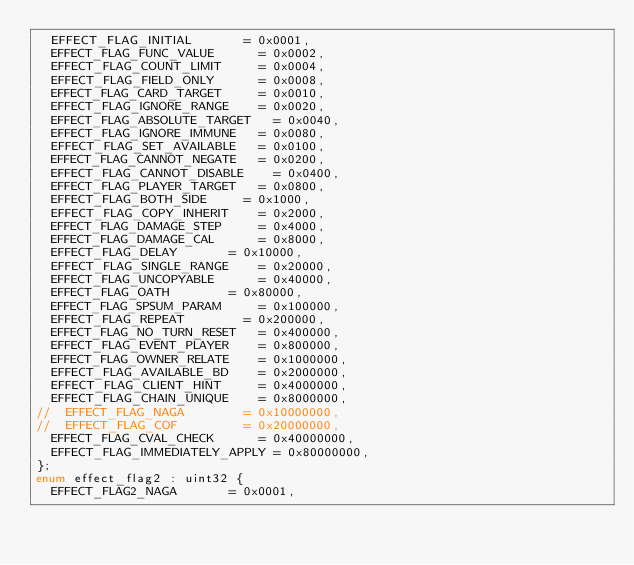<code> <loc_0><loc_0><loc_500><loc_500><_C_>	EFFECT_FLAG_INITIAL				= 0x0001,
	EFFECT_FLAG_FUNC_VALUE			= 0x0002,
	EFFECT_FLAG_COUNT_LIMIT			= 0x0004,
	EFFECT_FLAG_FIELD_ONLY			= 0x0008,
	EFFECT_FLAG_CARD_TARGET			= 0x0010,
	EFFECT_FLAG_IGNORE_RANGE		= 0x0020,
	EFFECT_FLAG_ABSOLUTE_TARGET		= 0x0040,
	EFFECT_FLAG_IGNORE_IMMUNE		= 0x0080,
	EFFECT_FLAG_SET_AVAILABLE		= 0x0100,
	EFFECT_FLAG_CANNOT_NEGATE		= 0x0200,
	EFFECT_FLAG_CANNOT_DISABLE		= 0x0400,
	EFFECT_FLAG_PLAYER_TARGET		= 0x0800,
	EFFECT_FLAG_BOTH_SIDE			= 0x1000,
	EFFECT_FLAG_COPY_INHERIT		= 0x2000,
	EFFECT_FLAG_DAMAGE_STEP			= 0x4000,
	EFFECT_FLAG_DAMAGE_CAL			= 0x8000,
	EFFECT_FLAG_DELAY				= 0x10000,
	EFFECT_FLAG_SINGLE_RANGE		= 0x20000,
	EFFECT_FLAG_UNCOPYABLE			= 0x40000,
	EFFECT_FLAG_OATH				= 0x80000,
	EFFECT_FLAG_SPSUM_PARAM			= 0x100000,
	EFFECT_FLAG_REPEAT				= 0x200000,
	EFFECT_FLAG_NO_TURN_RESET		= 0x400000,
	EFFECT_FLAG_EVENT_PLAYER		= 0x800000,
	EFFECT_FLAG_OWNER_RELATE		= 0x1000000,
	EFFECT_FLAG_AVAILABLE_BD		= 0x2000000,
	EFFECT_FLAG_CLIENT_HINT			= 0x4000000,
	EFFECT_FLAG_CHAIN_UNIQUE		= 0x8000000,
//	EFFECT_FLAG_NAGA				= 0x10000000,
//	EFFECT_FLAG_COF					= 0x20000000,
	EFFECT_FLAG_CVAL_CHECK			= 0x40000000,
	EFFECT_FLAG_IMMEDIATELY_APPLY	= 0x80000000,
};
enum effect_flag2 : uint32 {
	EFFECT_FLAG2_NAGA				= 0x0001,</code> 